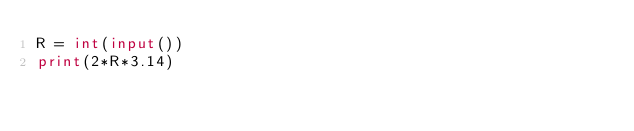Convert code to text. <code><loc_0><loc_0><loc_500><loc_500><_Python_>R = int(input())
print(2*R*3.14)</code> 